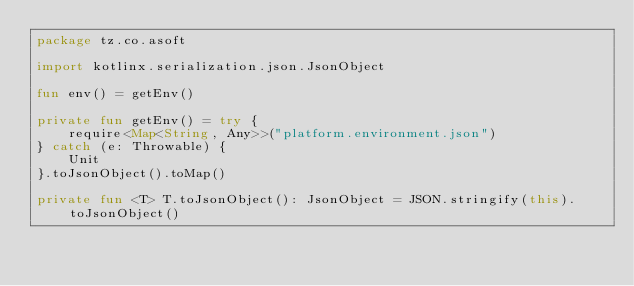<code> <loc_0><loc_0><loc_500><loc_500><_Kotlin_>package tz.co.asoft

import kotlinx.serialization.json.JsonObject

fun env() = getEnv()

private fun getEnv() = try {
    require<Map<String, Any>>("platform.environment.json")
} catch (e: Throwable) {
    Unit
}.toJsonObject().toMap()

private fun <T> T.toJsonObject(): JsonObject = JSON.stringify(this).toJsonObject()</code> 